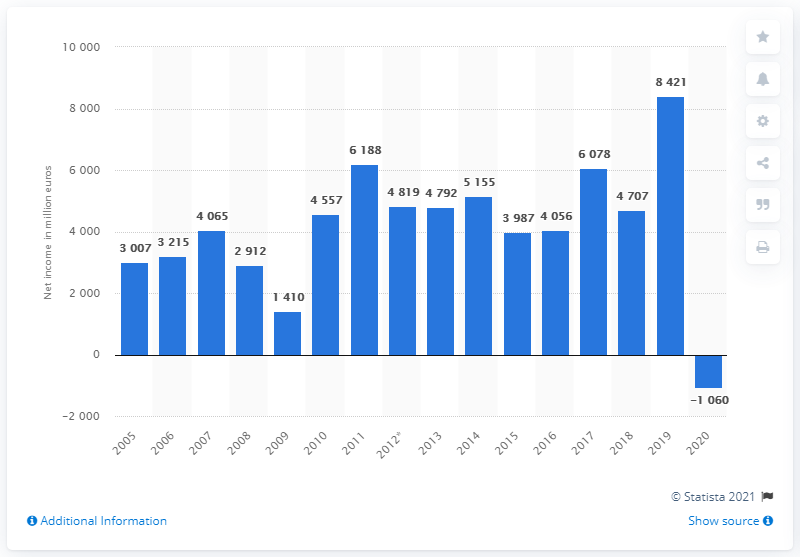Draw attention to some important aspects in this diagram. BASF's net income in the previous year was approximately 8,421. 